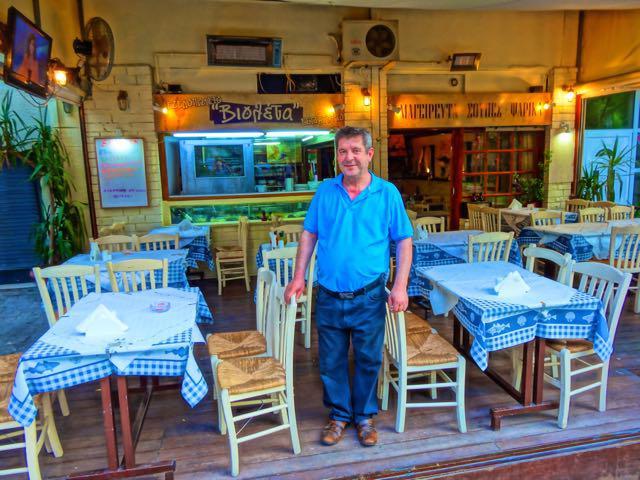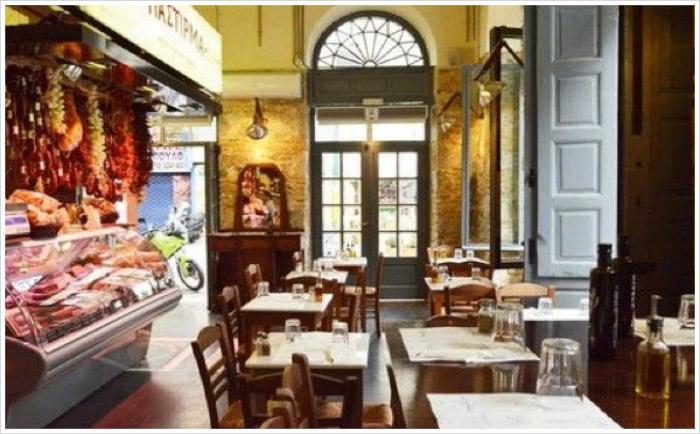The first image is the image on the left, the second image is the image on the right. For the images displayed, is the sentence "The left image features a man standing and facing-forward in the middle of rectangular tables with rail-backed chairs around them." factually correct? Answer yes or no. Yes. The first image is the image on the left, the second image is the image on the right. For the images shown, is this caption "All of the tables are covered with cloths." true? Answer yes or no. No. 